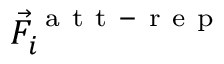<formula> <loc_0><loc_0><loc_500><loc_500>\vec { F } _ { i } ^ { a t t - r e p }</formula> 